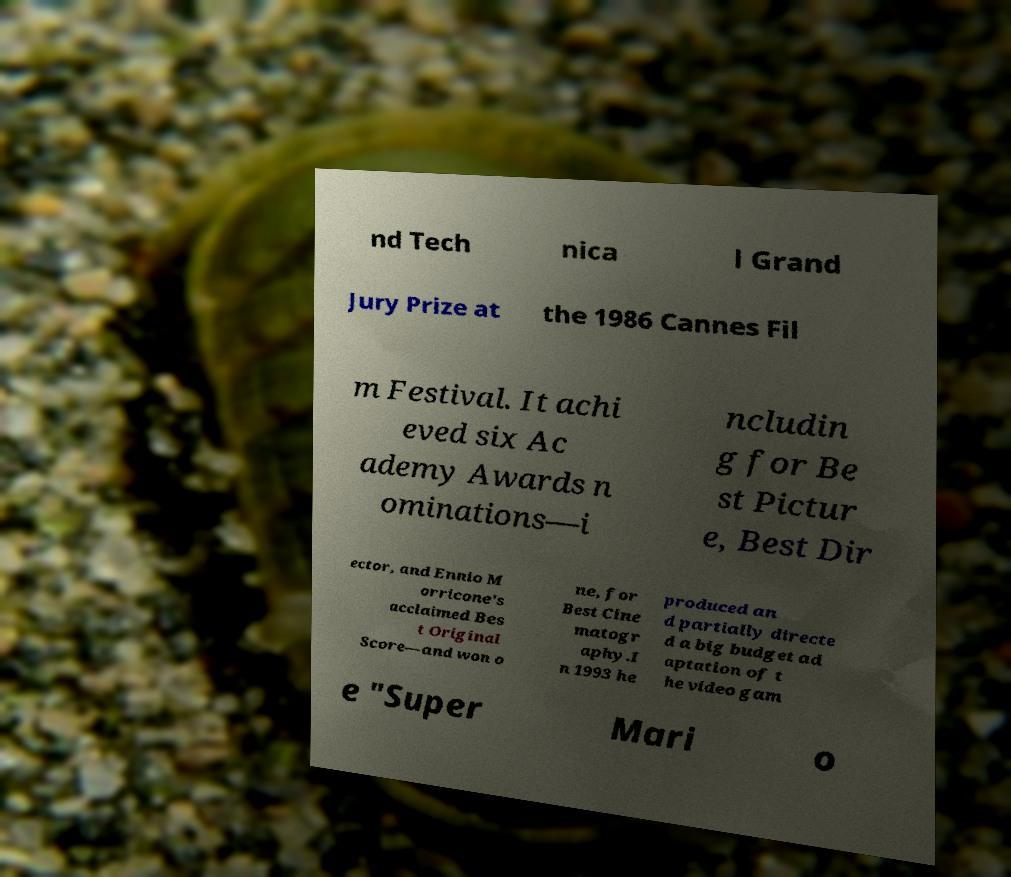Can you accurately transcribe the text from the provided image for me? nd Tech nica l Grand Jury Prize at the 1986 Cannes Fil m Festival. It achi eved six Ac ademy Awards n ominations—i ncludin g for Be st Pictur e, Best Dir ector, and Ennio M orricone's acclaimed Bes t Original Score—and won o ne, for Best Cine matogr aphy.I n 1993 he produced an d partially directe d a big budget ad aptation of t he video gam e "Super Mari o 